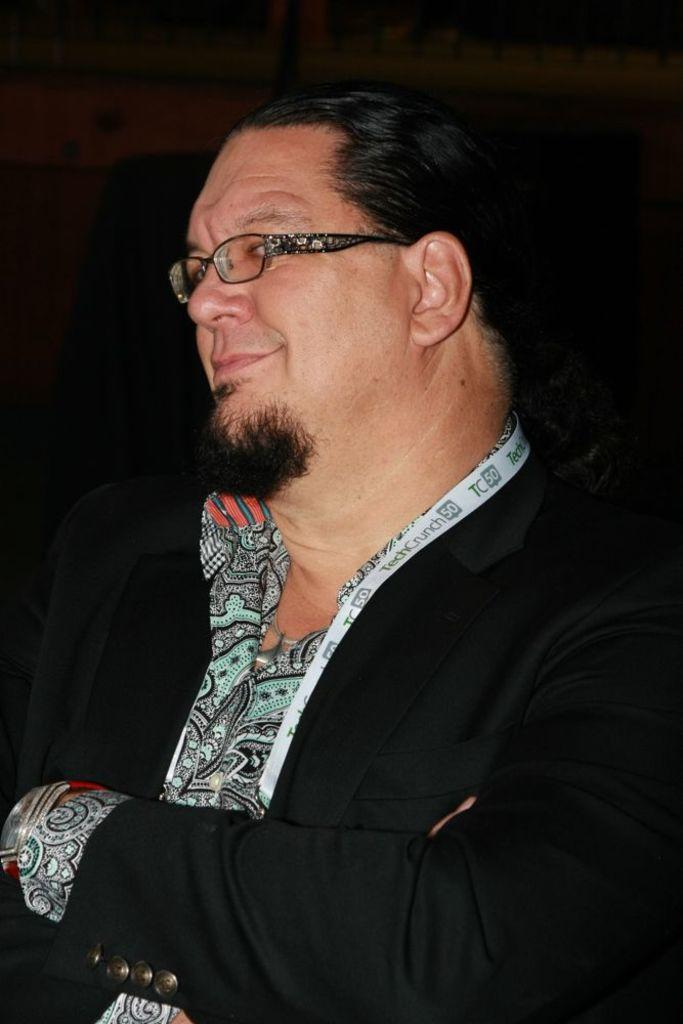What is present in the image? There is a person in the image. Can you describe the person's clothing? The person is wearing a black coat. Are there any accessories visible on the person? Yes, the person is wearing glasses (specs). How many jellyfish are swimming near the person in the image? There are no jellyfish present in the image. What type of ghost is visible behind the person in the image? There is no ghost present in the image. 